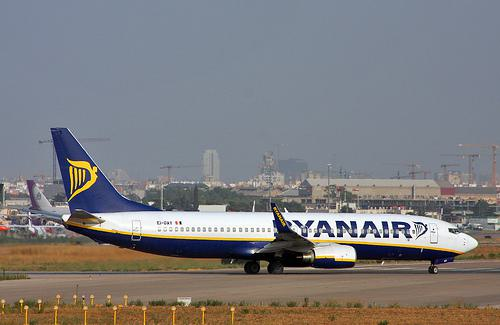What airline does the plane belong to, and can you tell which model it is? The plane in the image is operated by Ryanair, which is indicated by the logo and livery on the aircraft. Based on its appearance, it looks like a Boeing 737, a common model in their fleet. 